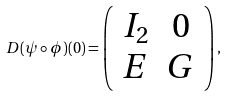Convert formula to latex. <formula><loc_0><loc_0><loc_500><loc_500>D ( \psi \circ \phi ) ( 0 ) = \left ( \begin{array} { c c } I _ { 2 } & 0 \\ E & G \end{array} \right ) ,</formula> 